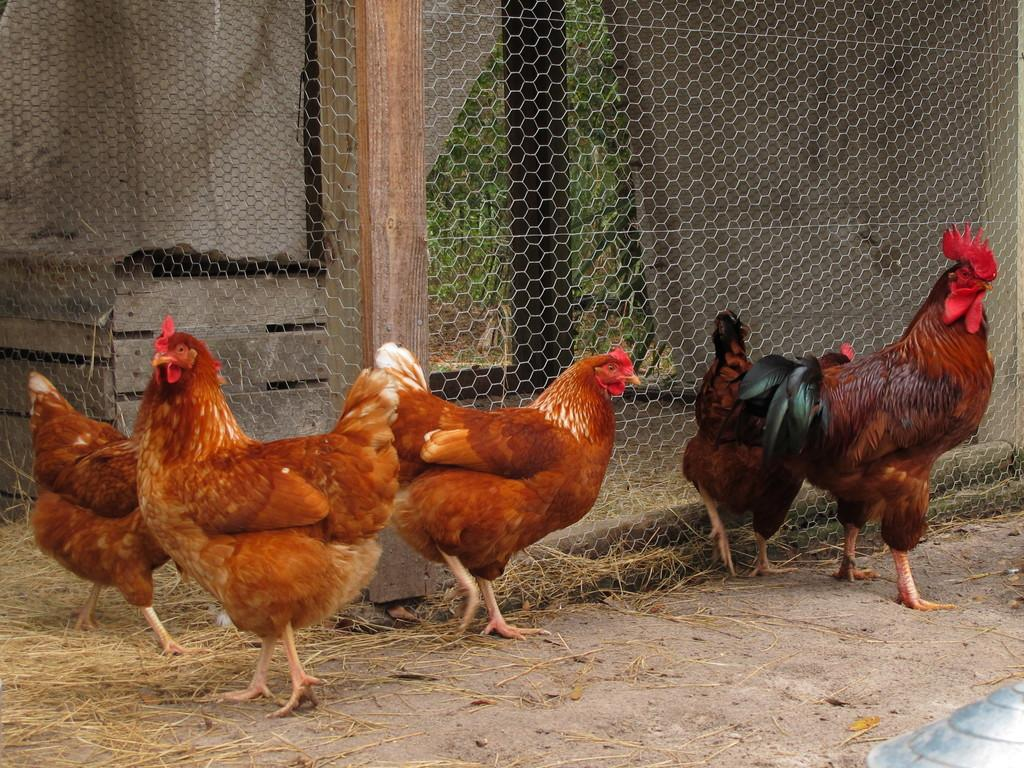What animals are on the floor in the image? There are hens on the floor in the image. What type of vegetation is on the floor in the image? There is dry grass on the floor in the image. What can be seen surrounding the area in the image? There is fencing visible in the image. What type of industry is depicted in the image? There is no industry depicted in the image; it features hens on the floor with dry grass and fencing. How can one join the hens in the image? There is no way to join the hens in the image, as they are not engaging in any activity that would allow for interaction. 